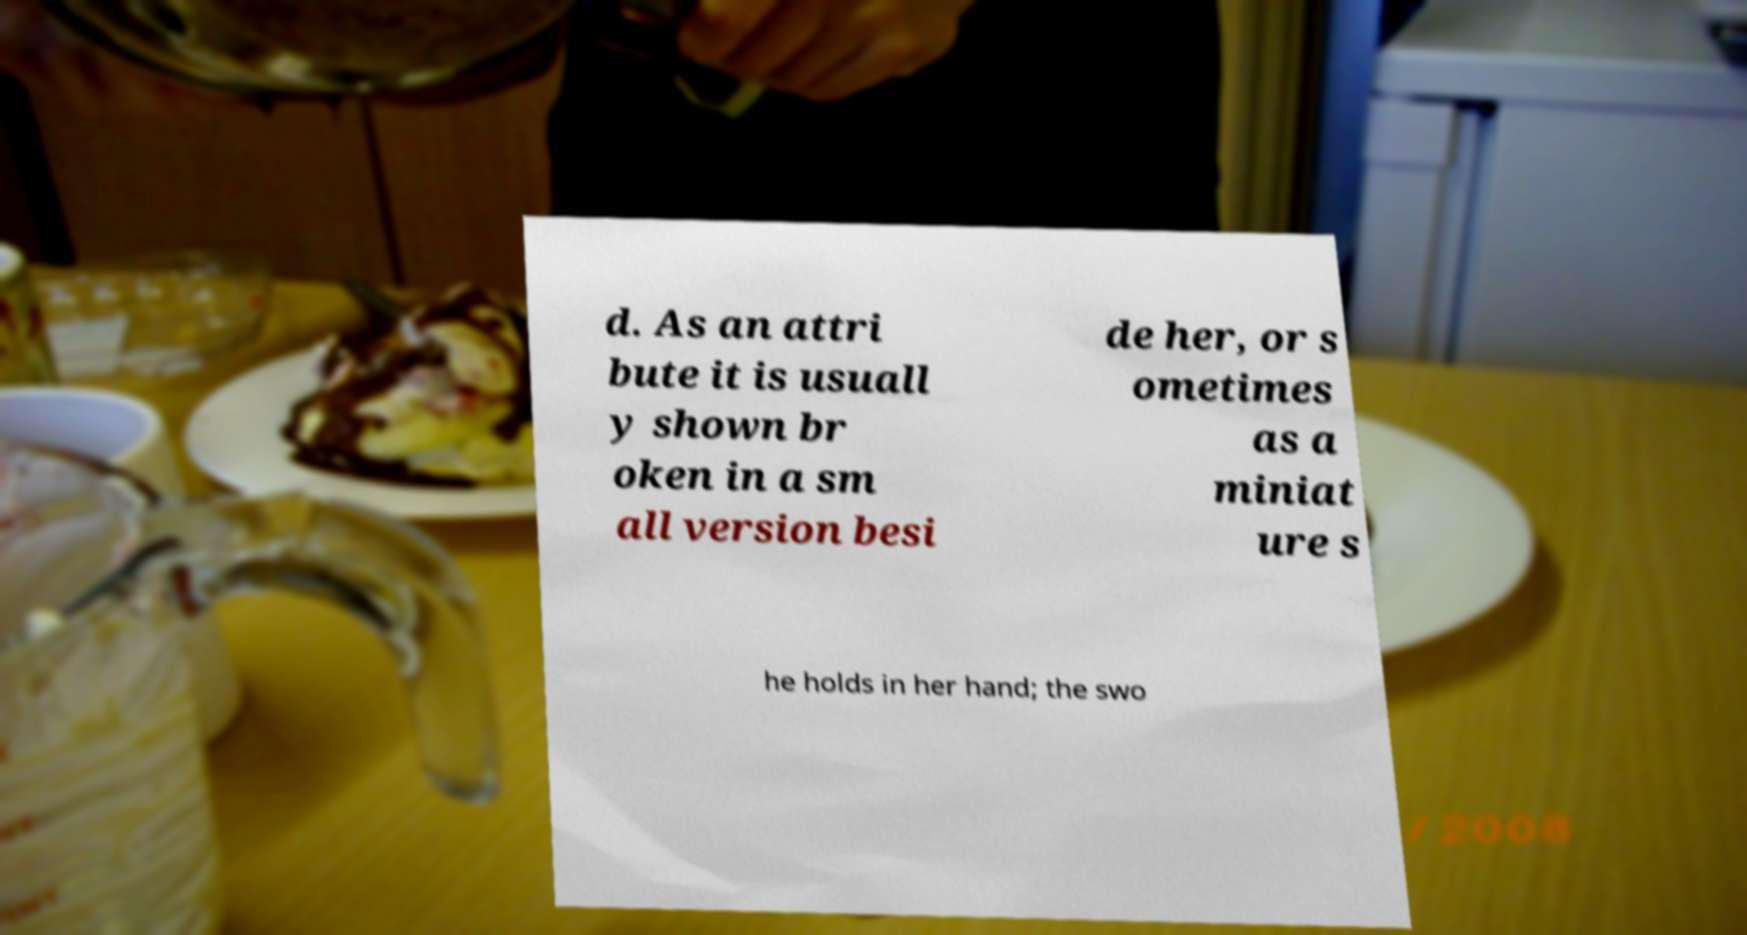Please read and relay the text visible in this image. What does it say? d. As an attri bute it is usuall y shown br oken in a sm all version besi de her, or s ometimes as a miniat ure s he holds in her hand; the swo 